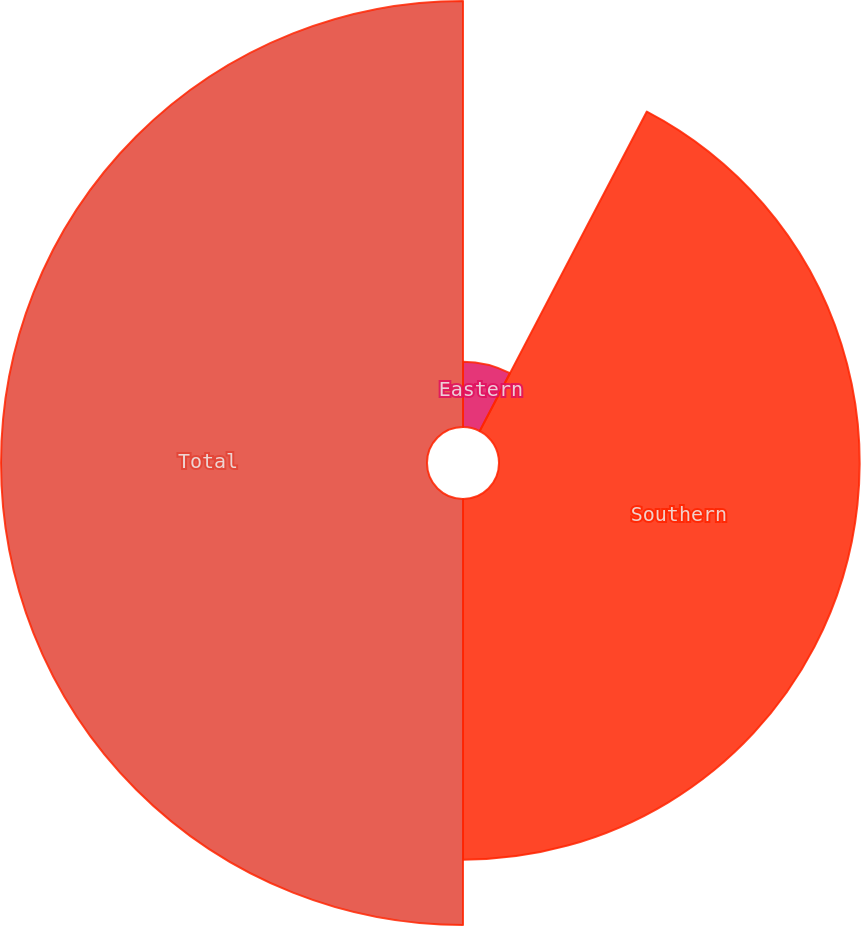Convert chart to OTSL. <chart><loc_0><loc_0><loc_500><loc_500><pie_chart><fcel>Eastern<fcel>Southern<fcel>Total<nl><fcel>7.67%<fcel>42.33%<fcel>50.0%<nl></chart> 